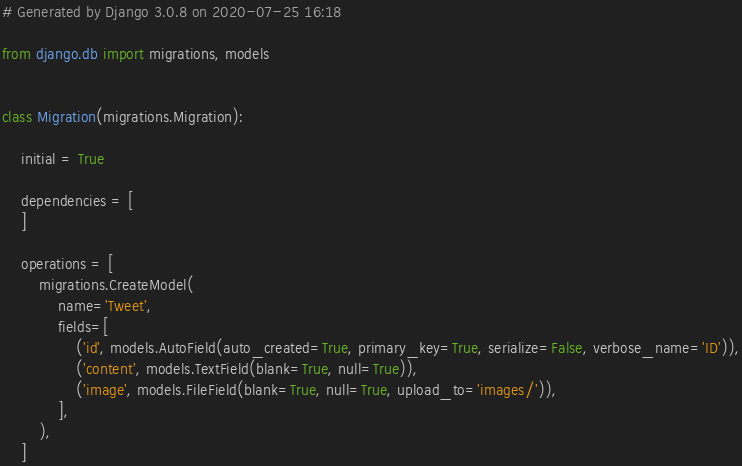Convert code to text. <code><loc_0><loc_0><loc_500><loc_500><_Python_># Generated by Django 3.0.8 on 2020-07-25 16:18

from django.db import migrations, models


class Migration(migrations.Migration):

    initial = True

    dependencies = [
    ]

    operations = [
        migrations.CreateModel(
            name='Tweet',
            fields=[
                ('id', models.AutoField(auto_created=True, primary_key=True, serialize=False, verbose_name='ID')),
                ('content', models.TextField(blank=True, null=True)),
                ('image', models.FileField(blank=True, null=True, upload_to='images/')),
            ],
        ),
    ]
</code> 